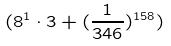<formula> <loc_0><loc_0><loc_500><loc_500>( 8 ^ { 1 } \cdot 3 + ( \frac { 1 } { 3 4 6 } ) ^ { 1 5 8 } )</formula> 